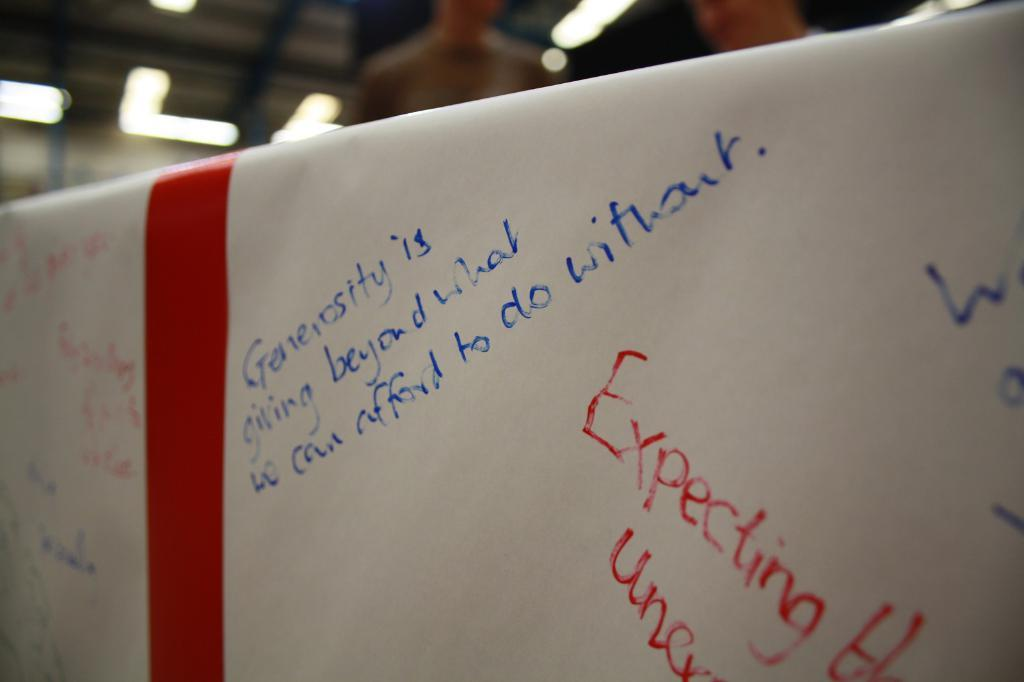<image>
Write a terse but informative summary of the picture. White board that says the word Generosity on it. 